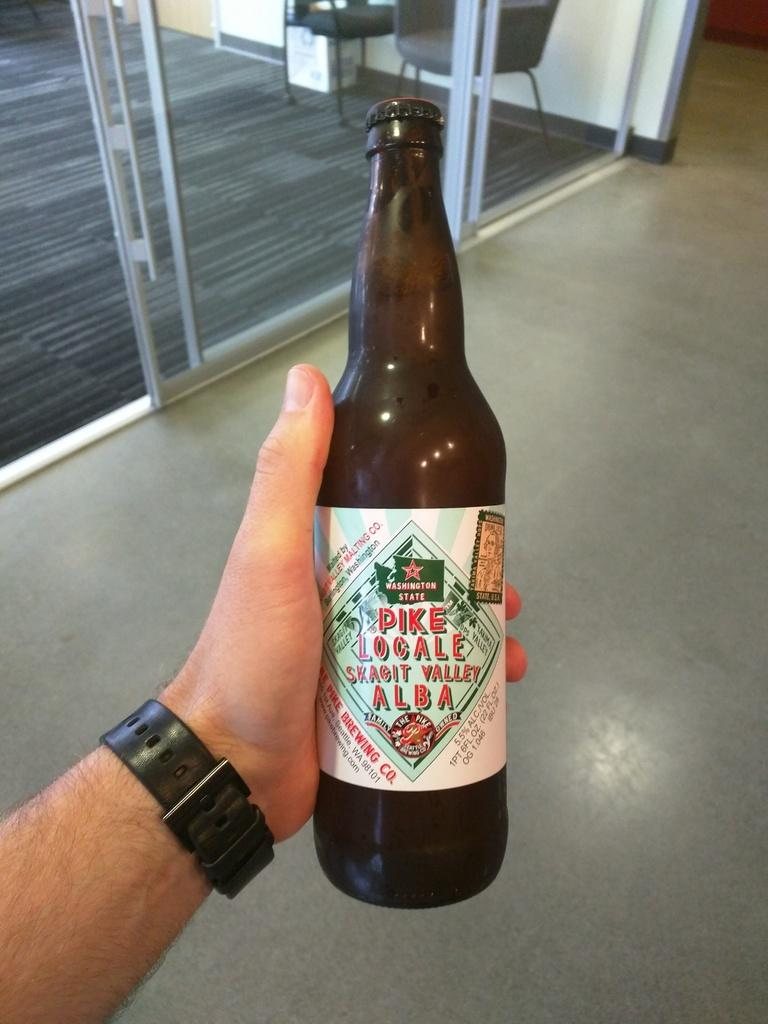<image>
Present a compact description of the photo's key features. A bottle of beer from the Pike Brewing Company. 